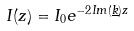<formula> <loc_0><loc_0><loc_500><loc_500>I ( z ) = I _ { 0 } e ^ { - 2 I m ( \underline { k } ) z }</formula> 